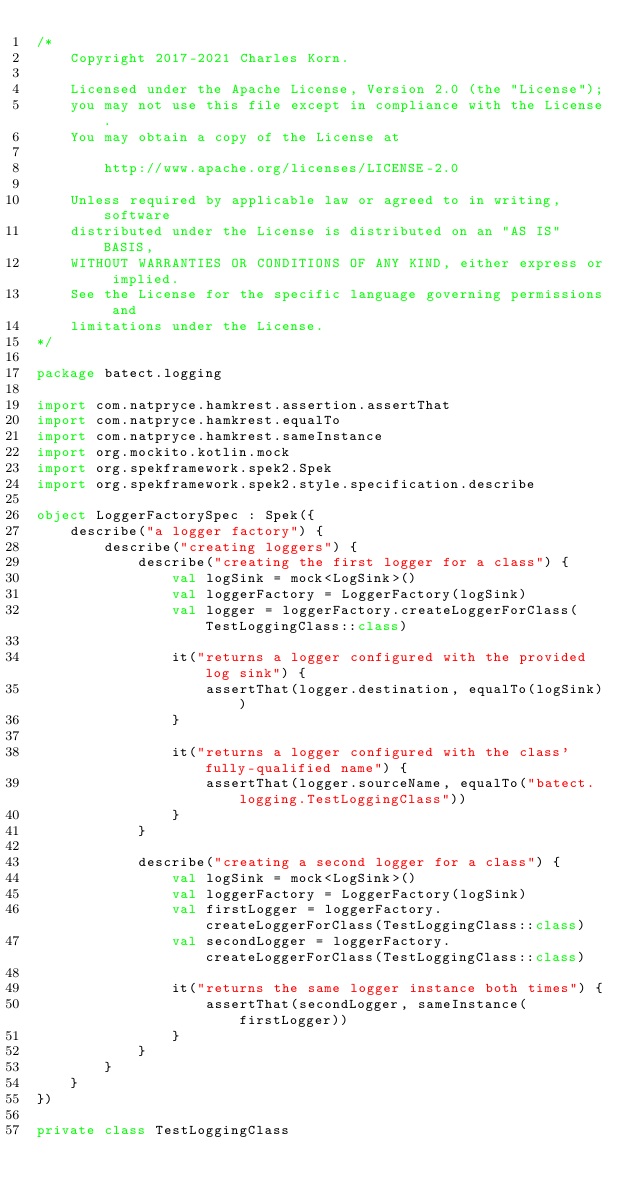Convert code to text. <code><loc_0><loc_0><loc_500><loc_500><_Kotlin_>/*
    Copyright 2017-2021 Charles Korn.

    Licensed under the Apache License, Version 2.0 (the "License");
    you may not use this file except in compliance with the License.
    You may obtain a copy of the License at

        http://www.apache.org/licenses/LICENSE-2.0

    Unless required by applicable law or agreed to in writing, software
    distributed under the License is distributed on an "AS IS" BASIS,
    WITHOUT WARRANTIES OR CONDITIONS OF ANY KIND, either express or implied.
    See the License for the specific language governing permissions and
    limitations under the License.
*/

package batect.logging

import com.natpryce.hamkrest.assertion.assertThat
import com.natpryce.hamkrest.equalTo
import com.natpryce.hamkrest.sameInstance
import org.mockito.kotlin.mock
import org.spekframework.spek2.Spek
import org.spekframework.spek2.style.specification.describe

object LoggerFactorySpec : Spek({
    describe("a logger factory") {
        describe("creating loggers") {
            describe("creating the first logger for a class") {
                val logSink = mock<LogSink>()
                val loggerFactory = LoggerFactory(logSink)
                val logger = loggerFactory.createLoggerForClass(TestLoggingClass::class)

                it("returns a logger configured with the provided log sink") {
                    assertThat(logger.destination, equalTo(logSink))
                }

                it("returns a logger configured with the class' fully-qualified name") {
                    assertThat(logger.sourceName, equalTo("batect.logging.TestLoggingClass"))
                }
            }

            describe("creating a second logger for a class") {
                val logSink = mock<LogSink>()
                val loggerFactory = LoggerFactory(logSink)
                val firstLogger = loggerFactory.createLoggerForClass(TestLoggingClass::class)
                val secondLogger = loggerFactory.createLoggerForClass(TestLoggingClass::class)

                it("returns the same logger instance both times") {
                    assertThat(secondLogger, sameInstance(firstLogger))
                }
            }
        }
    }
})

private class TestLoggingClass
</code> 